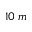Convert formula to latex. <formula><loc_0><loc_0><loc_500><loc_500>1 0 \, m</formula> 